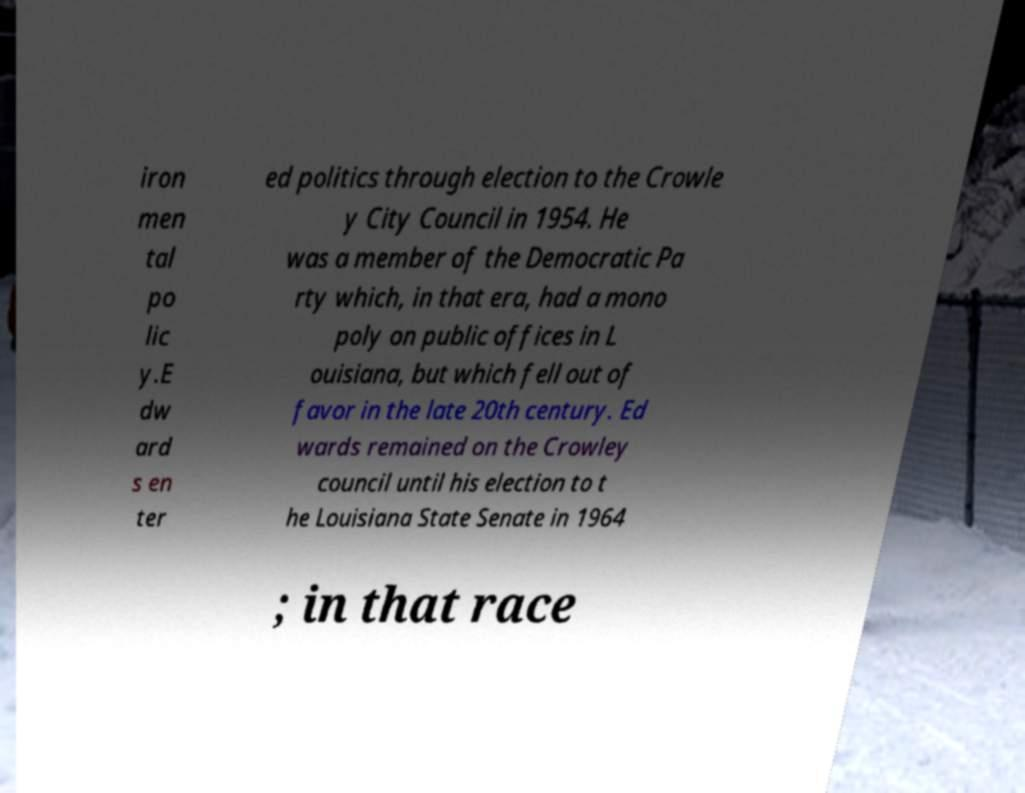Could you extract and type out the text from this image? iron men tal po lic y.E dw ard s en ter ed politics through election to the Crowle y City Council in 1954. He was a member of the Democratic Pa rty which, in that era, had a mono poly on public offices in L ouisiana, but which fell out of favor in the late 20th century. Ed wards remained on the Crowley council until his election to t he Louisiana State Senate in 1964 ; in that race 